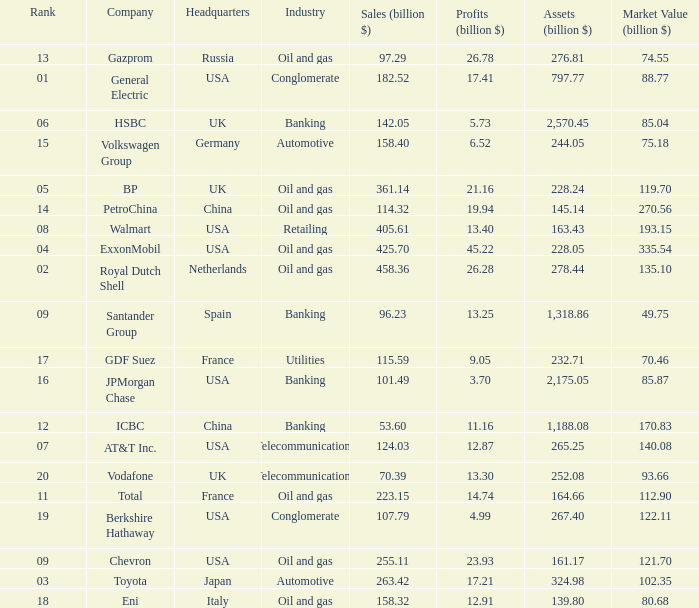How many Assets (billion $) has an Industry of oil and gas, and a Rank of 9, and a Market Value (billion $) larger than 121.7? None. 